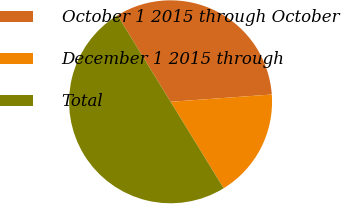Convert chart. <chart><loc_0><loc_0><loc_500><loc_500><pie_chart><fcel>October 1 2015 through October<fcel>December 1 2015 through<fcel>Total<nl><fcel>32.62%<fcel>17.38%<fcel>50.0%<nl></chart> 